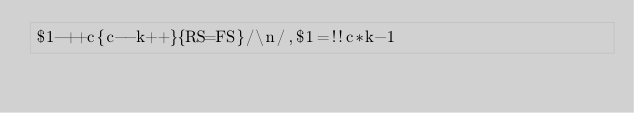<code> <loc_0><loc_0><loc_500><loc_500><_Awk_>$1-++c{c--k++}{RS=FS}/\n/,$1=!!c*k-1</code> 